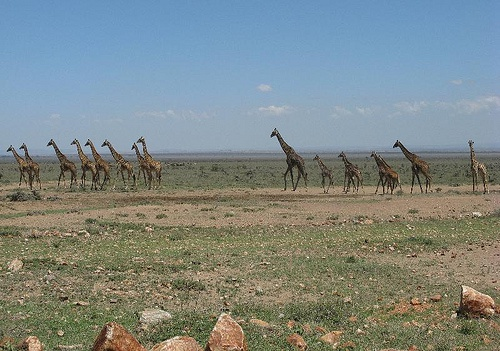Describe the objects in this image and their specific colors. I can see giraffe in gray, darkgray, and black tones, giraffe in gray and black tones, giraffe in gray and black tones, giraffe in gray and black tones, and giraffe in gray and black tones in this image. 